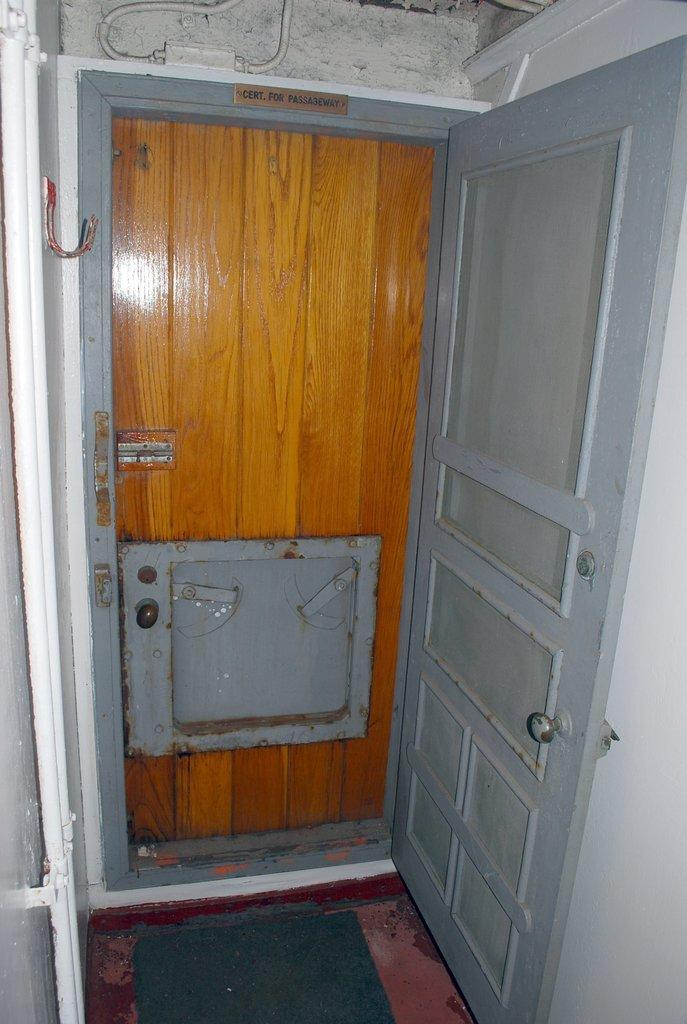How many doors are visible in the image? There are two doors in the image. What colors are the doors? One door is gray in color, and the other door is brown in color. What color is the wall in the image? The wall is white in color. What is the taste of the dirt on the floor in the image? There is no dirt present on the floor in the image, so it is not possible to determine its taste. 